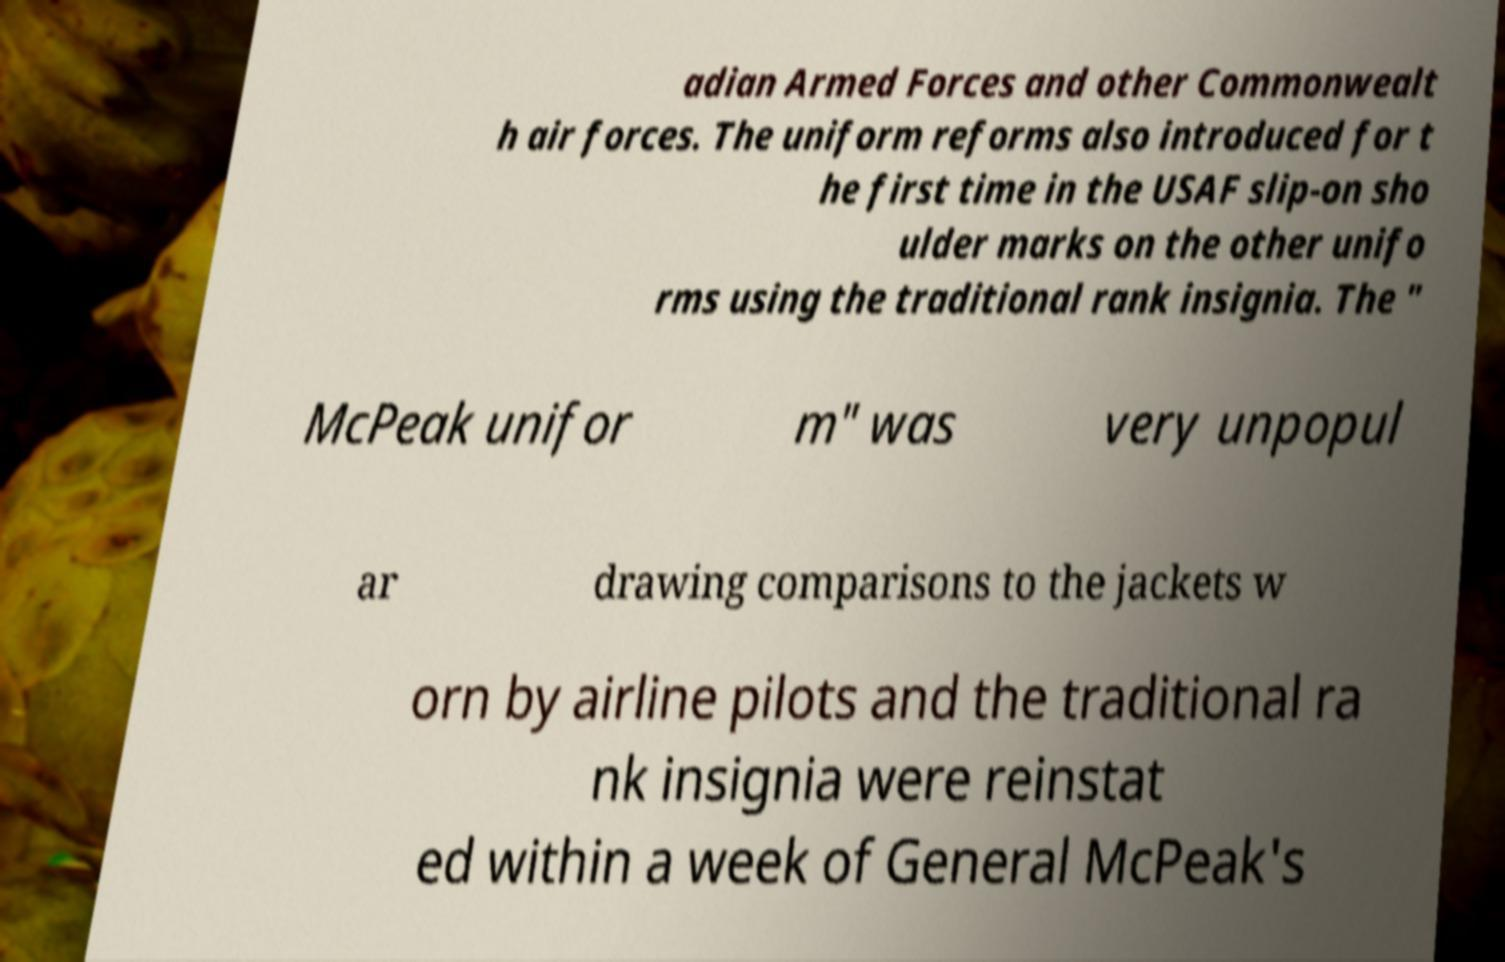What messages or text are displayed in this image? I need them in a readable, typed format. adian Armed Forces and other Commonwealt h air forces. The uniform reforms also introduced for t he first time in the USAF slip-on sho ulder marks on the other unifo rms using the traditional rank insignia. The " McPeak unifor m" was very unpopul ar drawing comparisons to the jackets w orn by airline pilots and the traditional ra nk insignia were reinstat ed within a week of General McPeak's 